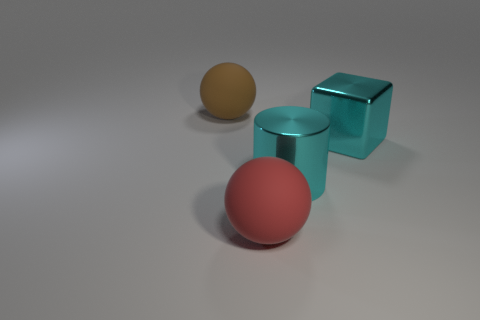Are the ball that is in front of the big brown ball and the big sphere behind the big red matte sphere made of the same material?
Your answer should be compact. Yes. What material is the cylinder?
Your answer should be compact. Metal. What number of cyan shiny things have the same shape as the large brown matte object?
Give a very brief answer. 0. There is a object that is the same color as the large cylinder; what is its material?
Your answer should be compact. Metal. Is there anything else that is the same shape as the brown object?
Keep it short and to the point. Yes. What is the color of the matte thing that is left of the large ball that is in front of the large cyan object that is to the left of the block?
Give a very brief answer. Brown. What number of small objects are either red matte things or green things?
Provide a short and direct response. 0. Are there an equal number of big rubber things in front of the brown thing and big cyan rubber balls?
Provide a short and direct response. No. Are there any large brown matte objects in front of the brown rubber sphere?
Offer a very short reply. No. What number of metallic things are either red cylinders or large cyan blocks?
Provide a succinct answer. 1. 